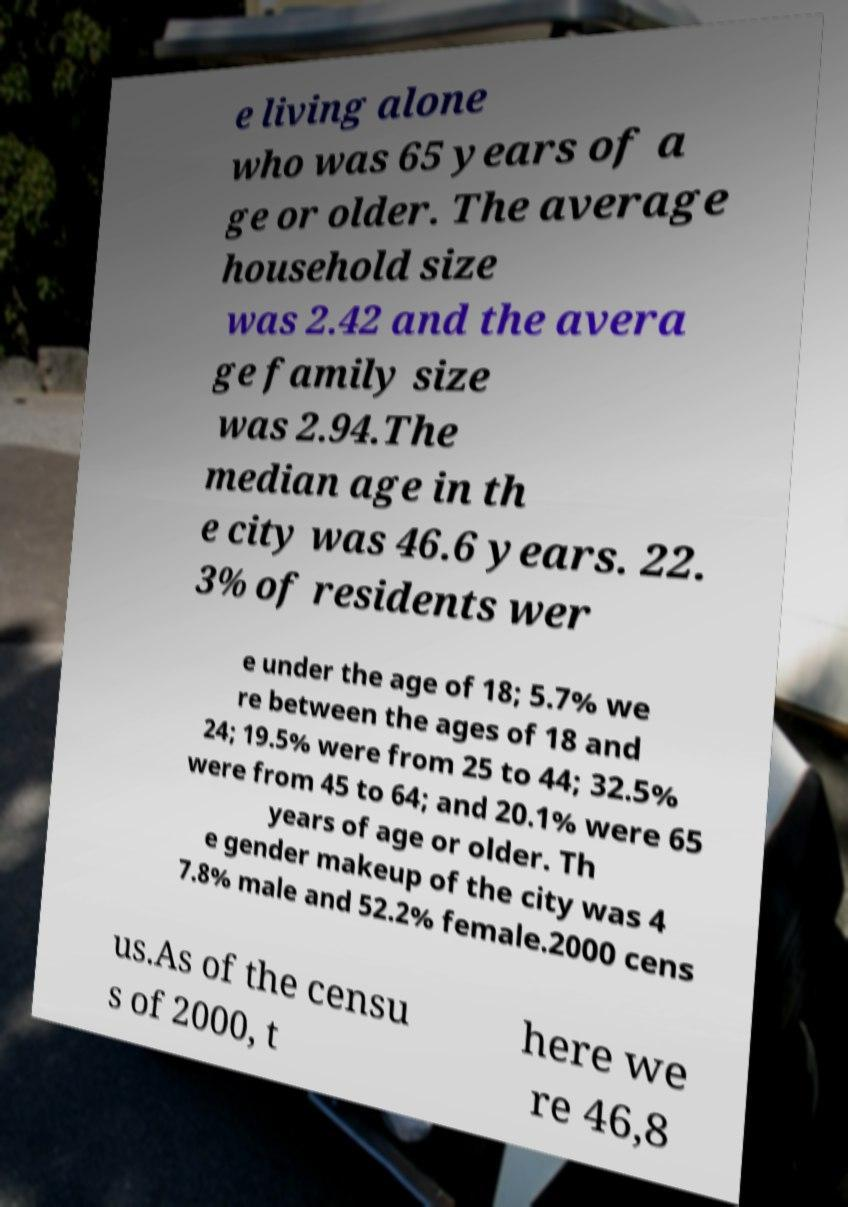Please identify and transcribe the text found in this image. e living alone who was 65 years of a ge or older. The average household size was 2.42 and the avera ge family size was 2.94.The median age in th e city was 46.6 years. 22. 3% of residents wer e under the age of 18; 5.7% we re between the ages of 18 and 24; 19.5% were from 25 to 44; 32.5% were from 45 to 64; and 20.1% were 65 years of age or older. Th e gender makeup of the city was 4 7.8% male and 52.2% female.2000 cens us.As of the censu s of 2000, t here we re 46,8 